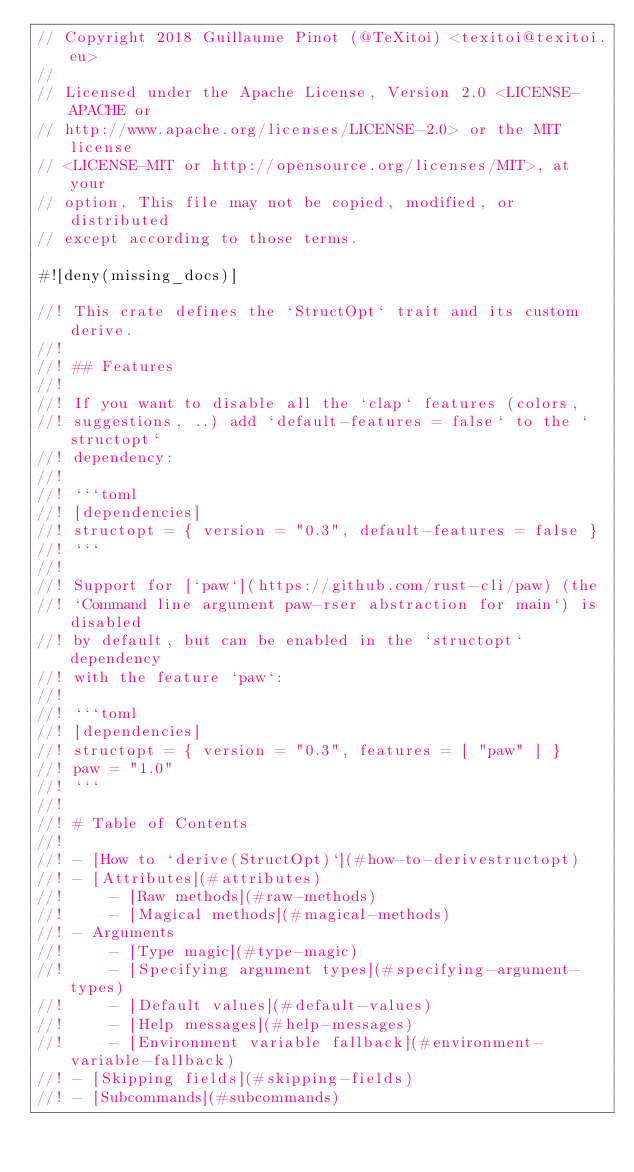<code> <loc_0><loc_0><loc_500><loc_500><_Rust_>// Copyright 2018 Guillaume Pinot (@TeXitoi) <texitoi@texitoi.eu>
//
// Licensed under the Apache License, Version 2.0 <LICENSE-APACHE or
// http://www.apache.org/licenses/LICENSE-2.0> or the MIT license
// <LICENSE-MIT or http://opensource.org/licenses/MIT>, at your
// option. This file may not be copied, modified, or distributed
// except according to those terms.

#![deny(missing_docs)]

//! This crate defines the `StructOpt` trait and its custom derive.
//!
//! ## Features
//!
//! If you want to disable all the `clap` features (colors,
//! suggestions, ..) add `default-features = false` to the `structopt`
//! dependency:
//!
//! ```toml
//! [dependencies]
//! structopt = { version = "0.3", default-features = false }
//! ```
//!
//! Support for [`paw`](https://github.com/rust-cli/paw) (the
//! `Command line argument paw-rser abstraction for main`) is disabled
//! by default, but can be enabled in the `structopt` dependency
//! with the feature `paw`:
//!
//! ```toml
//! [dependencies]
//! structopt = { version = "0.3", features = [ "paw" ] }
//! paw = "1.0"
//! ```
//!
//! # Table of Contents
//!
//! - [How to `derive(StructOpt)`](#how-to-derivestructopt)
//! - [Attributes](#attributes)
//!     - [Raw methods](#raw-methods)
//!     - [Magical methods](#magical-methods)
//! - Arguments
//!     - [Type magic](#type-magic)
//!     - [Specifying argument types](#specifying-argument-types)
//!     - [Default values](#default-values)
//!     - [Help messages](#help-messages)
//!     - [Environment variable fallback](#environment-variable-fallback)
//! - [Skipping fields](#skipping-fields)
//! - [Subcommands](#subcommands)</code> 